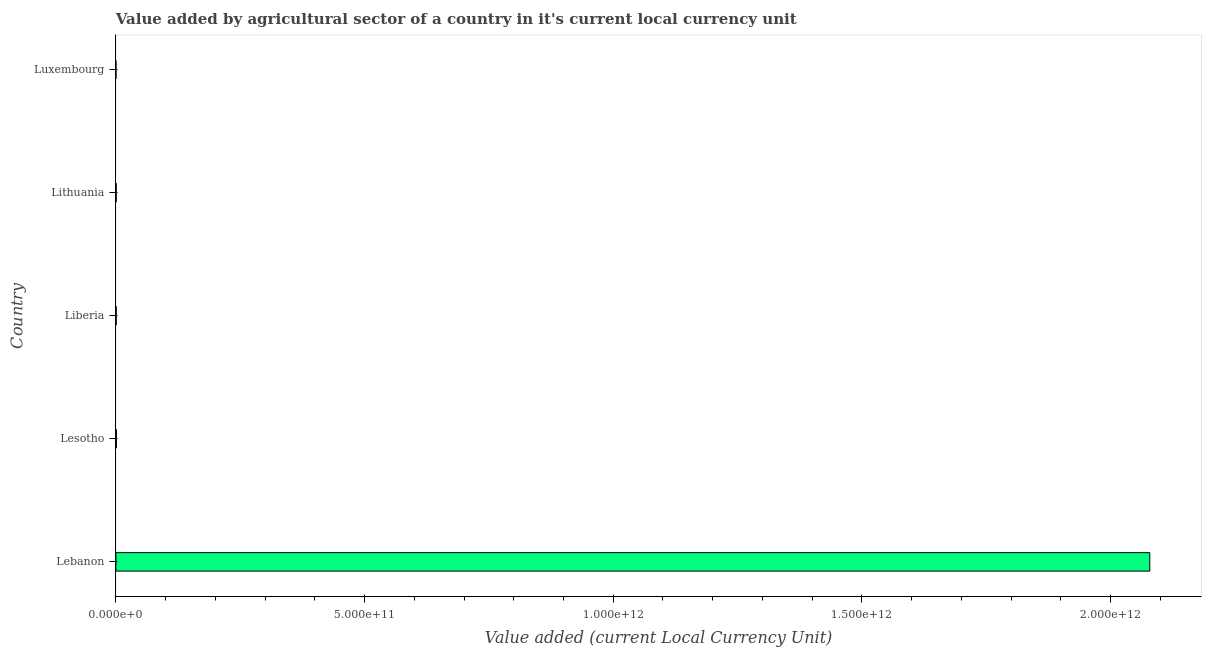What is the title of the graph?
Make the answer very short. Value added by agricultural sector of a country in it's current local currency unit. What is the label or title of the X-axis?
Ensure brevity in your answer.  Value added (current Local Currency Unit). What is the label or title of the Y-axis?
Offer a very short reply. Country. What is the value added by agriculture sector in Lithuania?
Make the answer very short. 6.82e+08. Across all countries, what is the maximum value added by agriculture sector?
Give a very brief answer. 2.08e+12. Across all countries, what is the minimum value added by agriculture sector?
Ensure brevity in your answer.  9.30e+07. In which country was the value added by agriculture sector maximum?
Make the answer very short. Lebanon. In which country was the value added by agriculture sector minimum?
Provide a short and direct response. Luxembourg. What is the sum of the value added by agriculture sector?
Your answer should be very brief. 2.08e+12. What is the difference between the value added by agriculture sector in Lesotho and Luxembourg?
Your response must be concise. 9.32e+08. What is the average value added by agriculture sector per country?
Your response must be concise. 4.16e+11. What is the median value added by agriculture sector?
Offer a very short reply. 6.82e+08. What is the ratio of the value added by agriculture sector in Liberia to that in Luxembourg?
Your answer should be very brief. 7.21. Is the value added by agriculture sector in Liberia less than that in Lithuania?
Keep it short and to the point. Yes. Is the difference between the value added by agriculture sector in Liberia and Lithuania greater than the difference between any two countries?
Offer a terse response. No. What is the difference between the highest and the second highest value added by agriculture sector?
Your response must be concise. 2.08e+12. What is the difference between the highest and the lowest value added by agriculture sector?
Ensure brevity in your answer.  2.08e+12. What is the difference between two consecutive major ticks on the X-axis?
Offer a terse response. 5.00e+11. Are the values on the major ticks of X-axis written in scientific E-notation?
Ensure brevity in your answer.  Yes. What is the Value added (current Local Currency Unit) in Lebanon?
Your answer should be compact. 2.08e+12. What is the Value added (current Local Currency Unit) of Lesotho?
Offer a very short reply. 1.02e+09. What is the Value added (current Local Currency Unit) in Liberia?
Offer a very short reply. 6.70e+08. What is the Value added (current Local Currency Unit) in Lithuania?
Provide a succinct answer. 6.82e+08. What is the Value added (current Local Currency Unit) of Luxembourg?
Your answer should be compact. 9.30e+07. What is the difference between the Value added (current Local Currency Unit) in Lebanon and Lesotho?
Keep it short and to the point. 2.08e+12. What is the difference between the Value added (current Local Currency Unit) in Lebanon and Liberia?
Give a very brief answer. 2.08e+12. What is the difference between the Value added (current Local Currency Unit) in Lebanon and Lithuania?
Ensure brevity in your answer.  2.08e+12. What is the difference between the Value added (current Local Currency Unit) in Lebanon and Luxembourg?
Provide a succinct answer. 2.08e+12. What is the difference between the Value added (current Local Currency Unit) in Lesotho and Liberia?
Your response must be concise. 3.54e+08. What is the difference between the Value added (current Local Currency Unit) in Lesotho and Lithuania?
Your answer should be compact. 3.42e+08. What is the difference between the Value added (current Local Currency Unit) in Lesotho and Luxembourg?
Offer a very short reply. 9.32e+08. What is the difference between the Value added (current Local Currency Unit) in Liberia and Lithuania?
Provide a succinct answer. -1.18e+07. What is the difference between the Value added (current Local Currency Unit) in Liberia and Luxembourg?
Provide a short and direct response. 5.77e+08. What is the difference between the Value added (current Local Currency Unit) in Lithuania and Luxembourg?
Your answer should be compact. 5.89e+08. What is the ratio of the Value added (current Local Currency Unit) in Lebanon to that in Lesotho?
Keep it short and to the point. 2028.84. What is the ratio of the Value added (current Local Currency Unit) in Lebanon to that in Liberia?
Provide a succinct answer. 3101.14. What is the ratio of the Value added (current Local Currency Unit) in Lebanon to that in Lithuania?
Provide a succinct answer. 3047.34. What is the ratio of the Value added (current Local Currency Unit) in Lebanon to that in Luxembourg?
Provide a short and direct response. 2.24e+04. What is the ratio of the Value added (current Local Currency Unit) in Lesotho to that in Liberia?
Keep it short and to the point. 1.53. What is the ratio of the Value added (current Local Currency Unit) in Lesotho to that in Lithuania?
Your answer should be compact. 1.5. What is the ratio of the Value added (current Local Currency Unit) in Lesotho to that in Luxembourg?
Provide a short and direct response. 11.02. What is the ratio of the Value added (current Local Currency Unit) in Liberia to that in Luxembourg?
Make the answer very short. 7.21. What is the ratio of the Value added (current Local Currency Unit) in Lithuania to that in Luxembourg?
Ensure brevity in your answer.  7.34. 